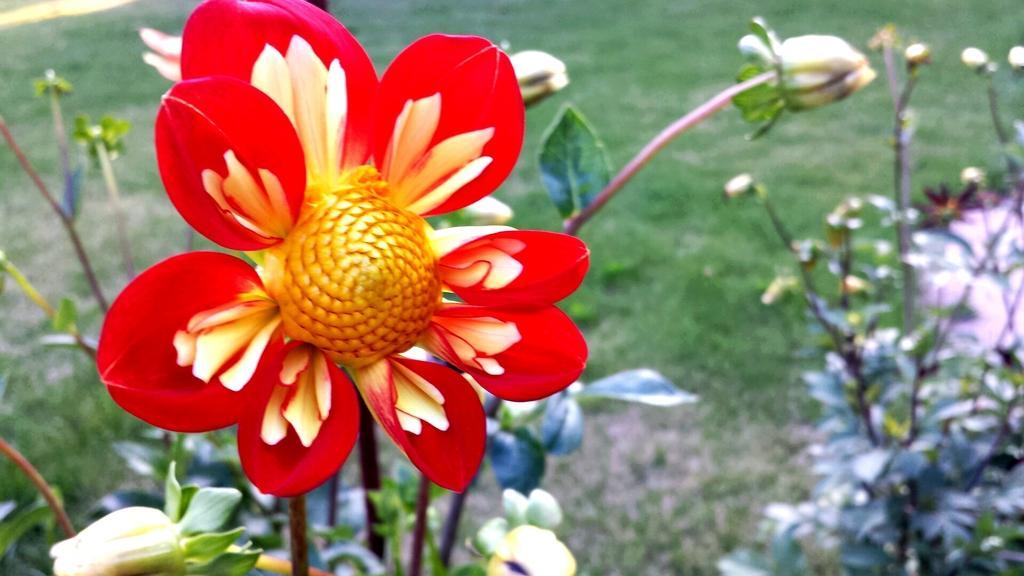Describe this image in one or two sentences. In the middle of the image we can see some flowers and plants. Behind them there is grass. 